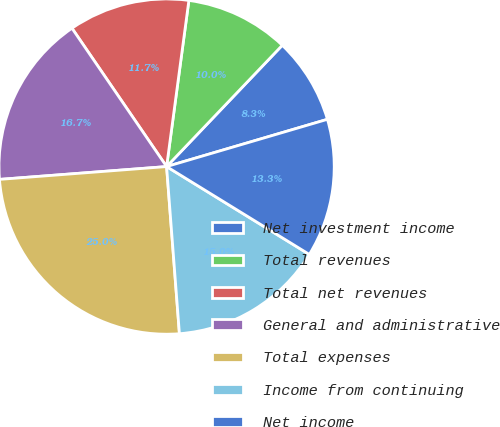Convert chart to OTSL. <chart><loc_0><loc_0><loc_500><loc_500><pie_chart><fcel>Net investment income<fcel>Total revenues<fcel>Total net revenues<fcel>General and administrative<fcel>Total expenses<fcel>Income from continuing<fcel>Net income<nl><fcel>8.33%<fcel>10.0%<fcel>11.67%<fcel>16.67%<fcel>25.0%<fcel>15.0%<fcel>13.33%<nl></chart> 